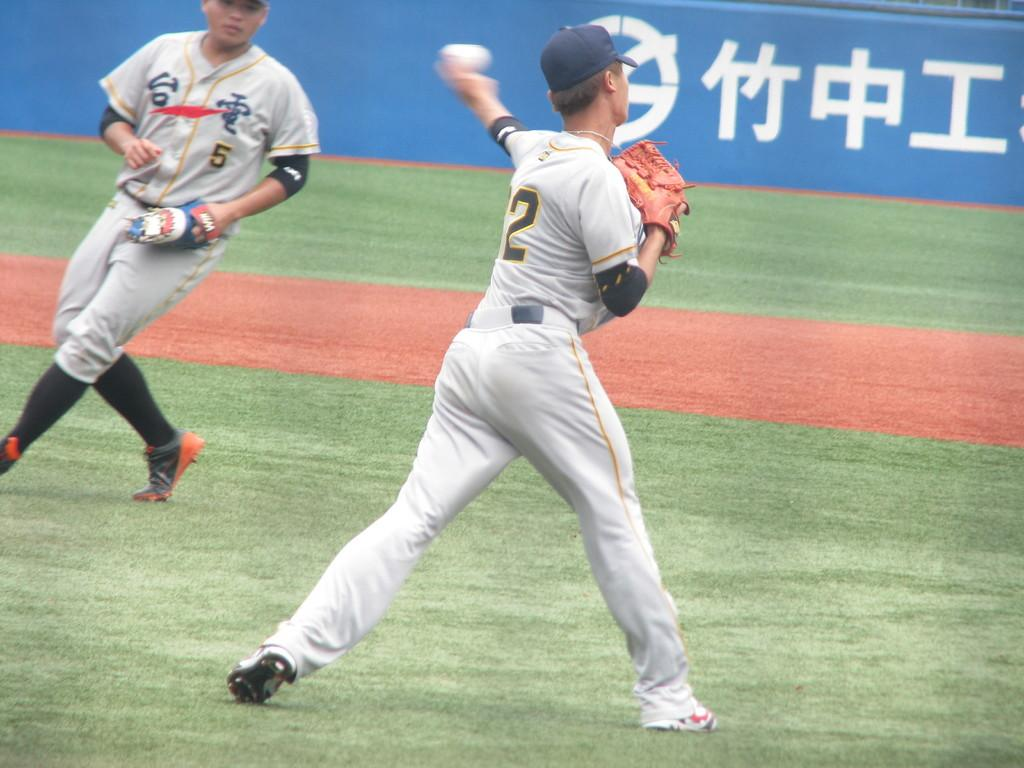<image>
Write a terse but informative summary of the picture. Baseball player wearing number 2 pitching the ball. 